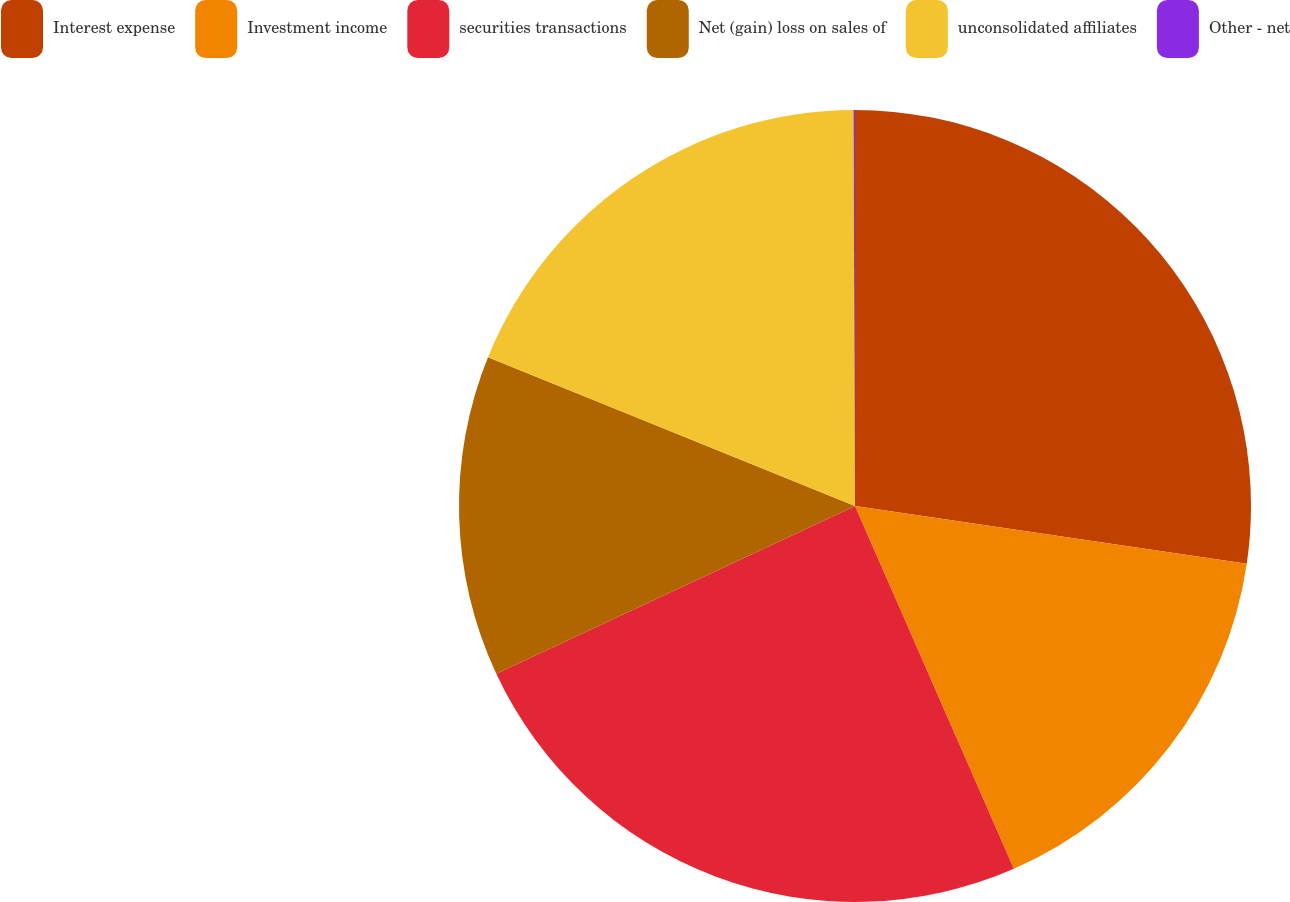Convert chart. <chart><loc_0><loc_0><loc_500><loc_500><pie_chart><fcel>Interest expense<fcel>Investment income<fcel>securities transactions<fcel>Net (gain) loss on sales of<fcel>unconsolidated affiliates<fcel>Other - net<nl><fcel>27.33%<fcel>16.1%<fcel>24.61%<fcel>13.09%<fcel>18.81%<fcel>0.06%<nl></chart> 